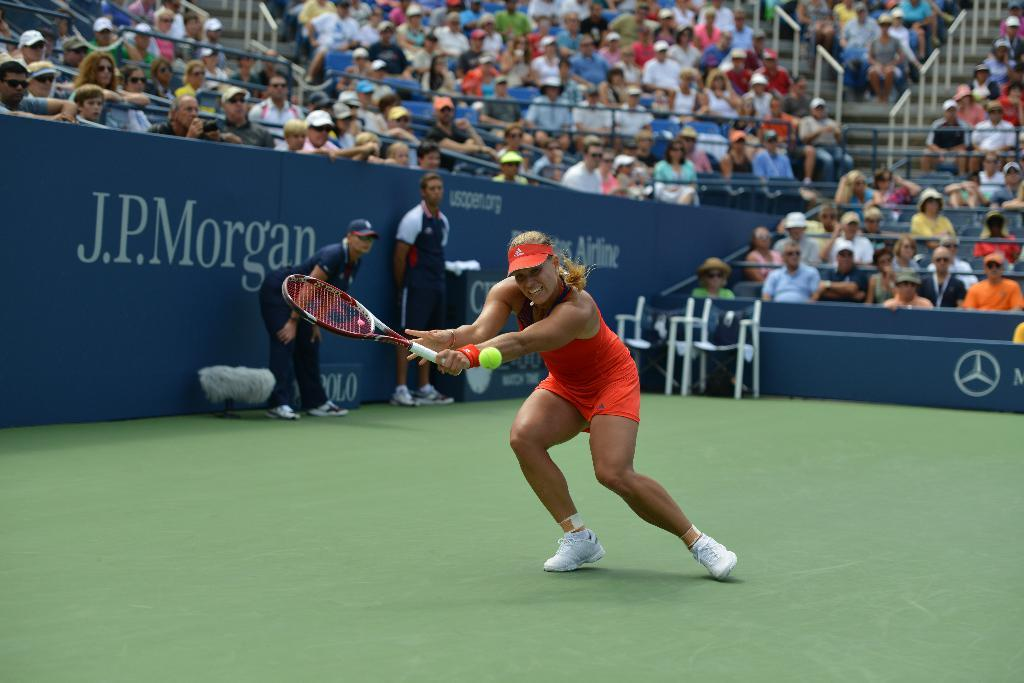Who is the main subject in the image? There is a lady in the image. What is the lady wearing? The lady is wearing an orange dress. What activity is the lady engaged in? The lady is playing tennis. Can you describe the setting of the image? There are spectators in the background of the image, and there are ball boys present as well. What type of brush is being used by the lady in the image? There is no brush present in the image; the lady is playing tennis with a tennis racket. 